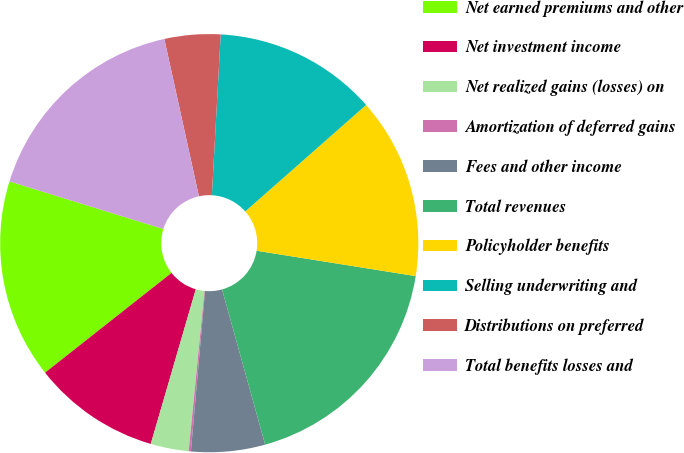<chart> <loc_0><loc_0><loc_500><loc_500><pie_chart><fcel>Net earned premiums and other<fcel>Net investment income<fcel>Net realized gains (losses) on<fcel>Amortization of deferred gains<fcel>Fees and other income<fcel>Total revenues<fcel>Policyholder benefits<fcel>Selling underwriting and<fcel>Distributions on preferred<fcel>Total benefits losses and<nl><fcel>15.4%<fcel>9.86%<fcel>2.94%<fcel>0.17%<fcel>5.71%<fcel>18.17%<fcel>14.01%<fcel>12.63%<fcel>4.32%<fcel>16.78%<nl></chart> 